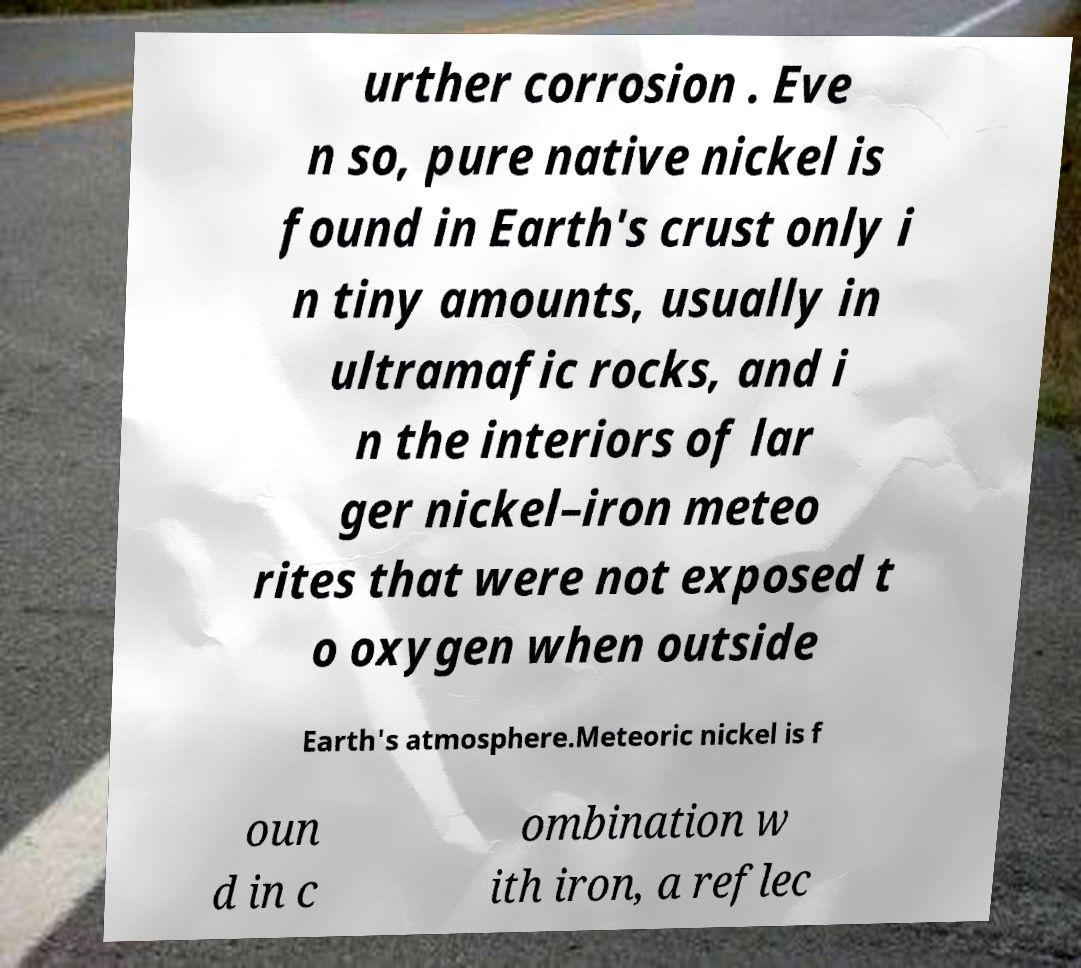Could you extract and type out the text from this image? urther corrosion . Eve n so, pure native nickel is found in Earth's crust only i n tiny amounts, usually in ultramafic rocks, and i n the interiors of lar ger nickel–iron meteo rites that were not exposed t o oxygen when outside Earth's atmosphere.Meteoric nickel is f oun d in c ombination w ith iron, a reflec 